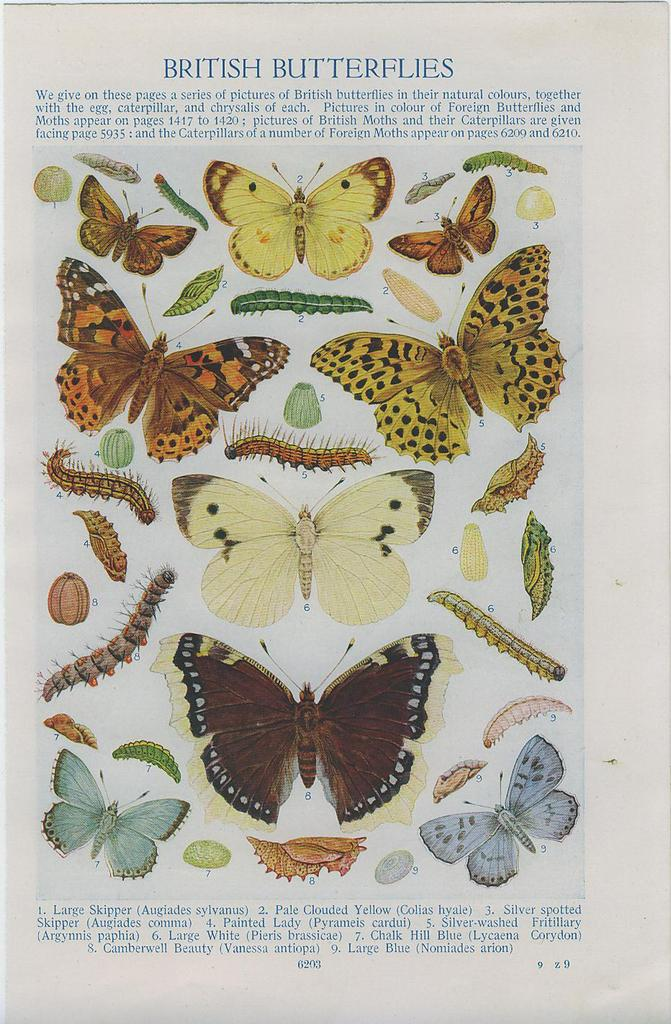What is the main topic of the article in the image? The article in the image is about butterflies. How many butterflies can be seen in the image? There are many butterflies in the image. Are there any other creatures visible in the image besides butterflies? Yes, there are worms in the image. What type of dolls are hanging from the curtain in the image? There are no dolls or curtains present in the image; it features an article about butterflies and worms. 